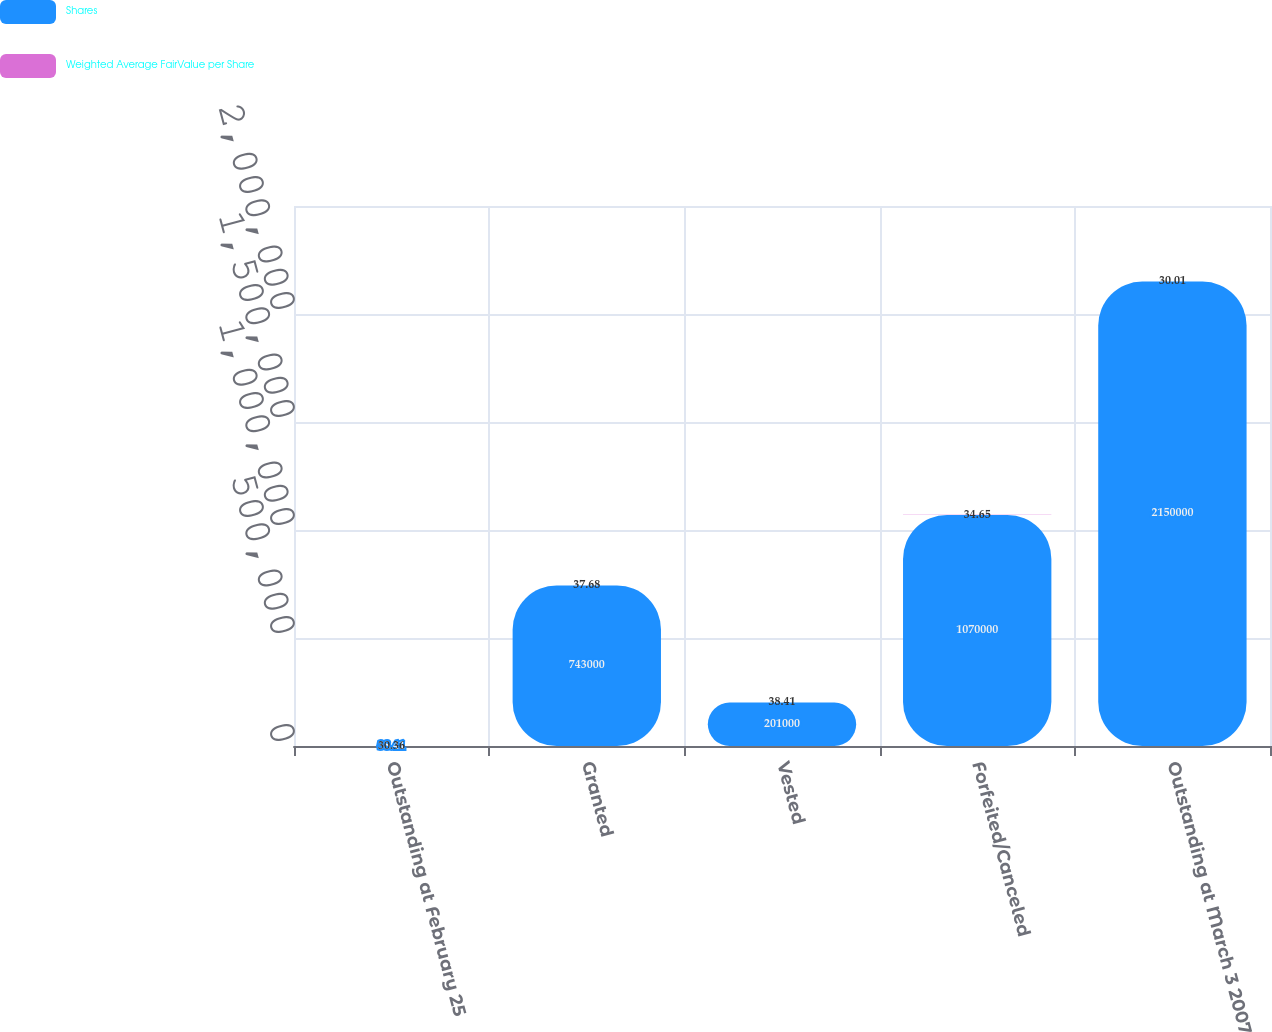Convert chart to OTSL. <chart><loc_0><loc_0><loc_500><loc_500><stacked_bar_chart><ecel><fcel>Outstanding at February 25<fcel>Granted<fcel>Vested<fcel>Forfeited/Canceled<fcel>Outstanding at March 3 2007<nl><fcel>Shares<fcel>38.41<fcel>743000<fcel>201000<fcel>1.07e+06<fcel>2.15e+06<nl><fcel>Weighted Average FairValue per Share<fcel>30.36<fcel>37.68<fcel>38.41<fcel>34.65<fcel>30.01<nl></chart> 